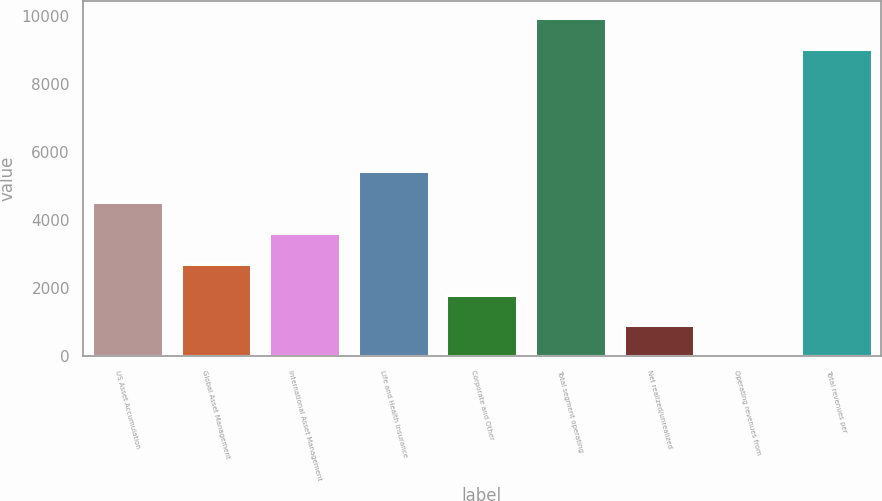Convert chart. <chart><loc_0><loc_0><loc_500><loc_500><bar_chart><fcel>US Asset Accumulation<fcel>Global Asset Management<fcel>International Asset Management<fcel>Life and Health Insurance<fcel>Corporate and Other<fcel>Total segment operating<fcel>Net realized/unrealized<fcel>Operating revenues from<fcel>Total revenues per<nl><fcel>4535.8<fcel>2723.44<fcel>3629.62<fcel>5441.98<fcel>1817.26<fcel>9945.78<fcel>911.08<fcel>4.9<fcel>9039.6<nl></chart> 